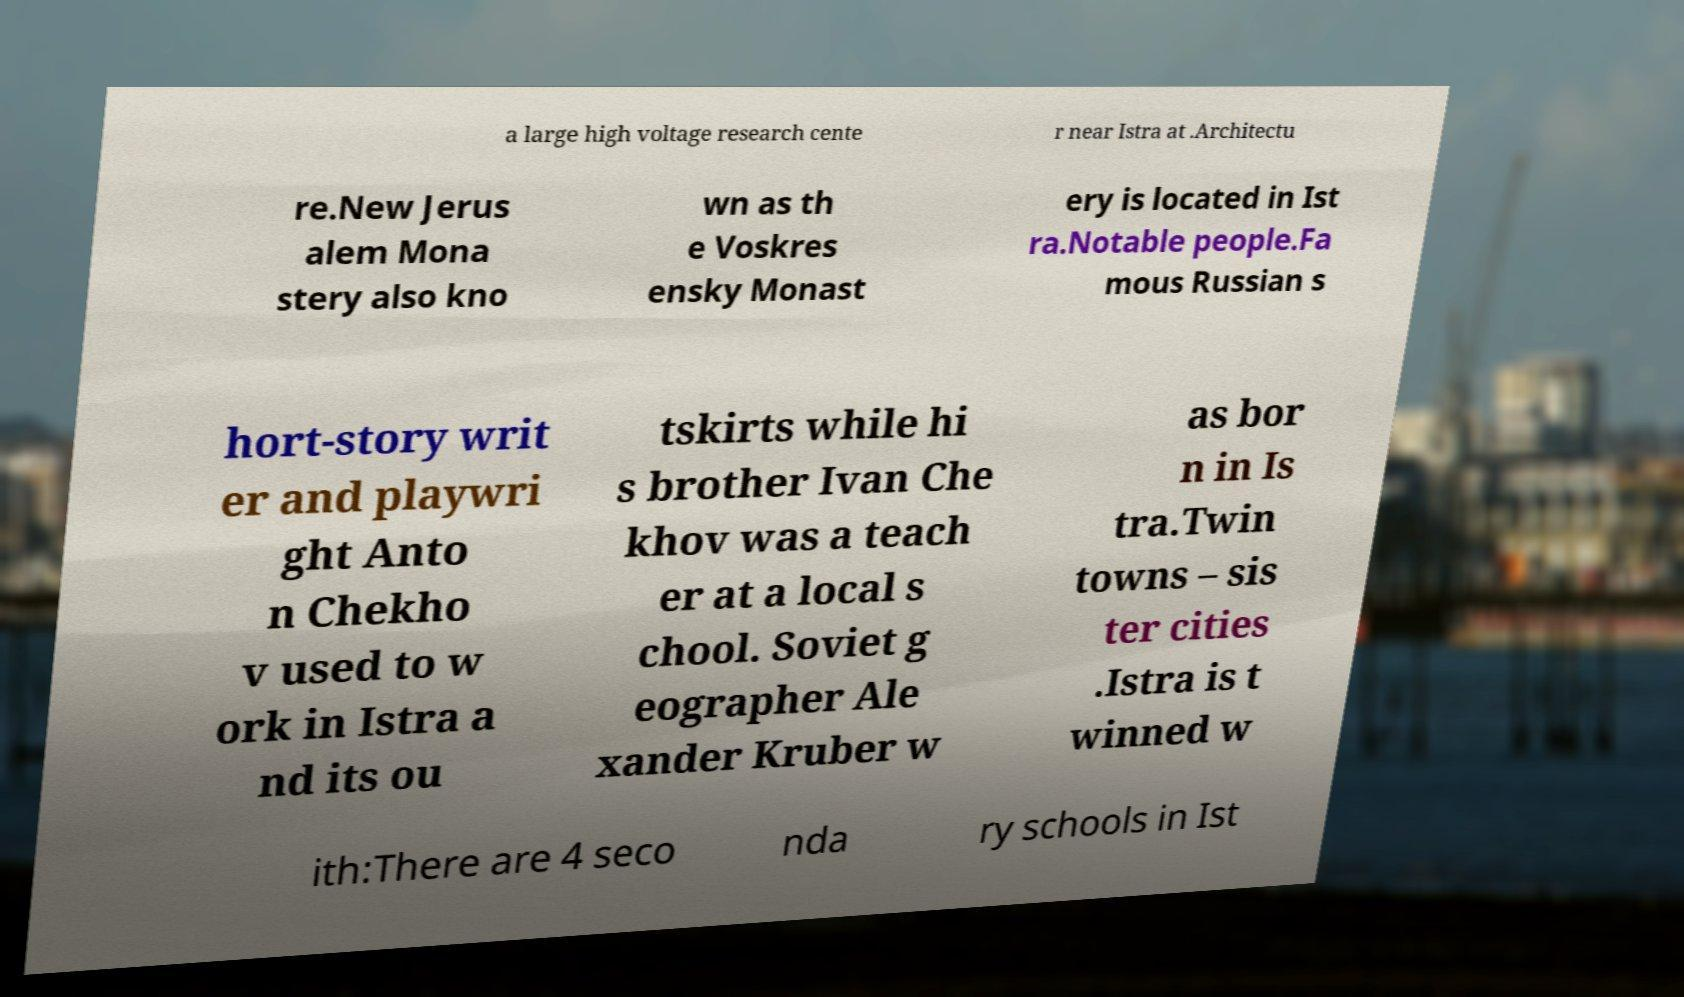Could you extract and type out the text from this image? a large high voltage research cente r near Istra at .Architectu re.New Jerus alem Mona stery also kno wn as th e Voskres ensky Monast ery is located in Ist ra.Notable people.Fa mous Russian s hort-story writ er and playwri ght Anto n Chekho v used to w ork in Istra a nd its ou tskirts while hi s brother Ivan Che khov was a teach er at a local s chool. Soviet g eographer Ale xander Kruber w as bor n in Is tra.Twin towns – sis ter cities .Istra is t winned w ith:There are 4 seco nda ry schools in Ist 